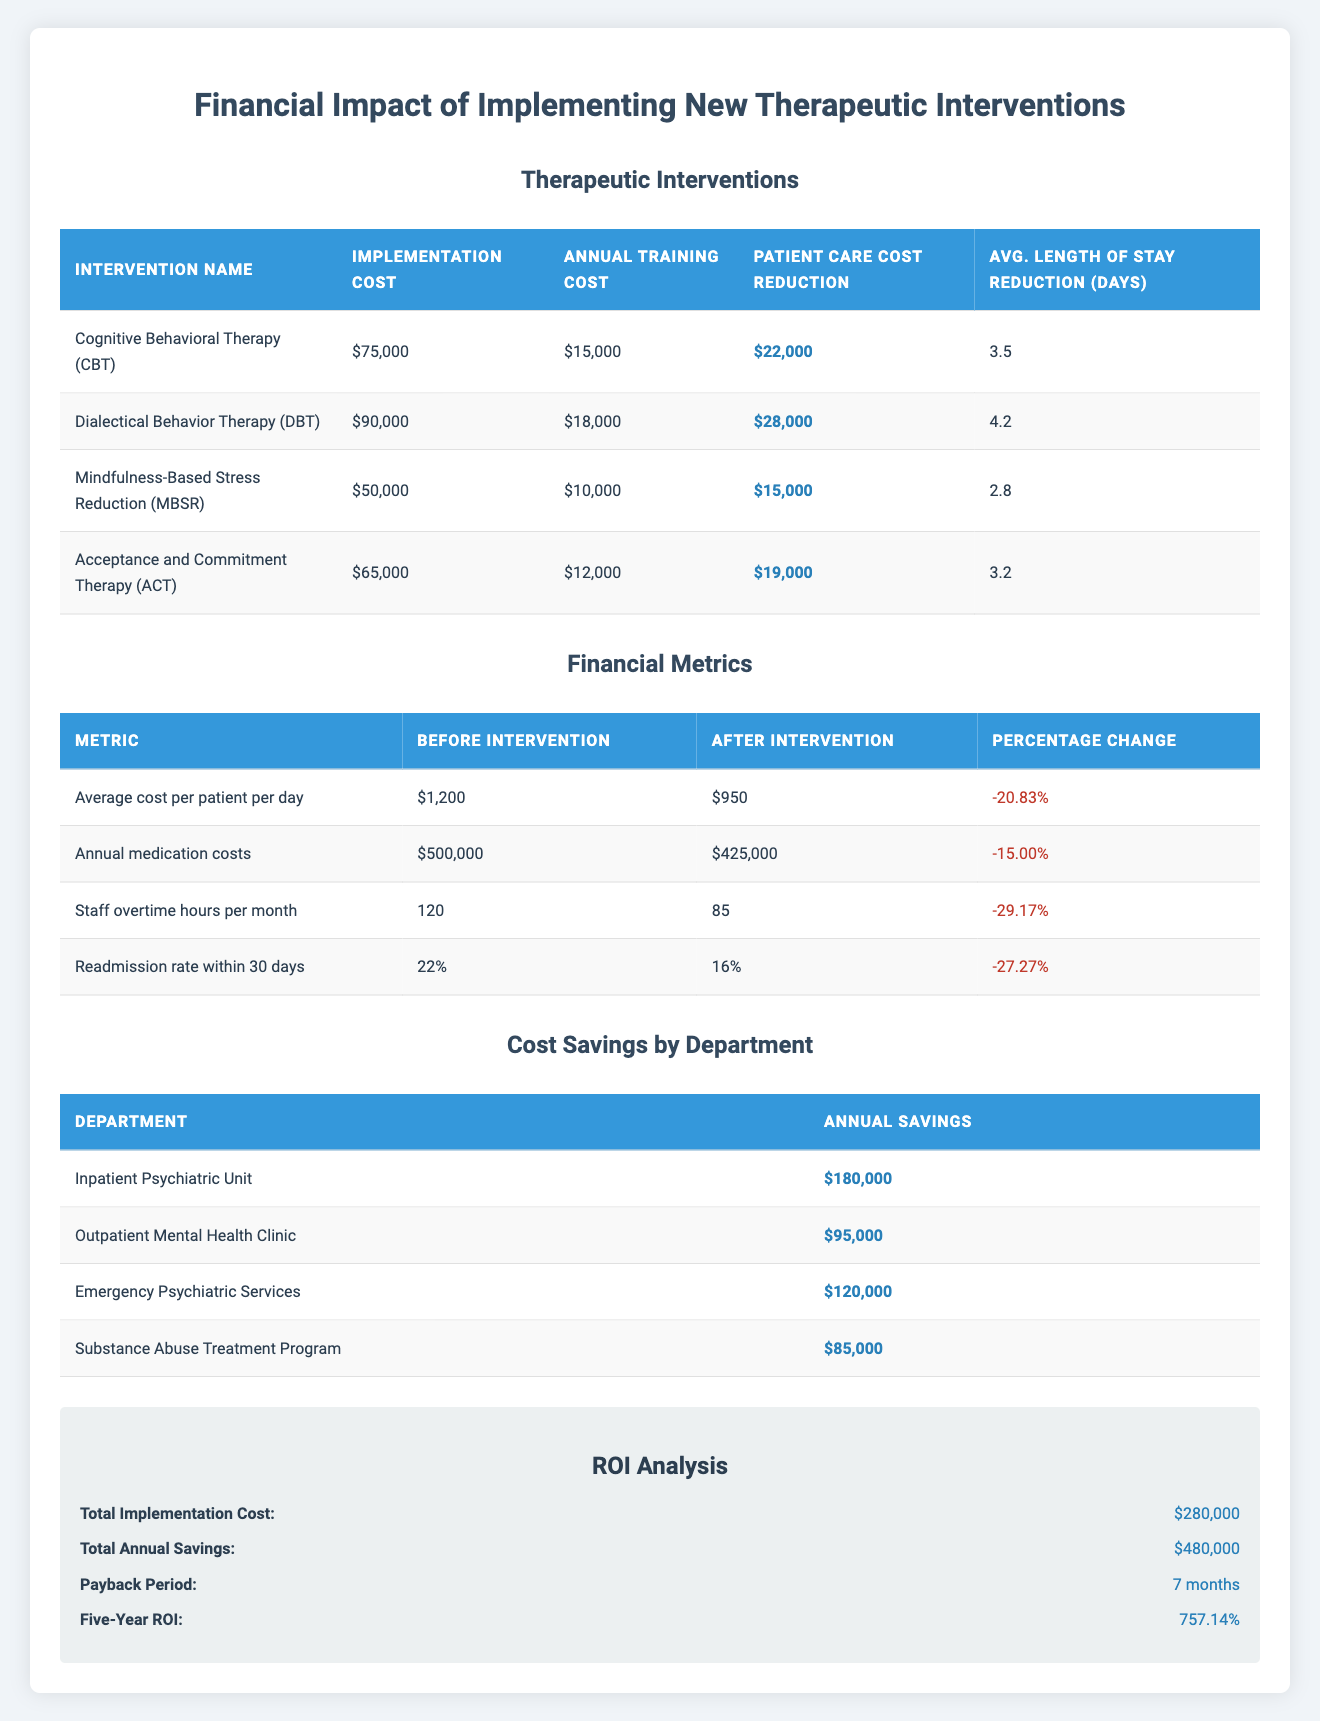What is the implementation cost of Dialectical Behavior Therapy (DBT)? The implementation cost of DBT is listed in the table as $90,000.
Answer: $90,000 What is the annual training cost for Mindfulness-Based Stress Reduction (MBSR)? The annual training cost for MBSR can be found in the table and is stated as $10,000.
Answer: $10,000 How much did patient care costs reduce with Cognitive Behavioral Therapy (CBT)? The reduction in patient care costs associated with CBT is noted in the table as $22,000.
Answer: $22,000 What is the total annual savings across all departments listed? By adding the annual savings from each department: 180,000 + 95,000 + 120,000 + 85,000 = 480,000.
Answer: $480,000 Did the implementation of these interventions reduce the average cost per patient per day? Yes, the average cost per patient per day decreased from $1,200 to $950, indicating a reduction.
Answer: Yes What is the average length of stay reduction for Dialectical Behavior Therapy (DBT)? The reduction in the average length of stay for DBT is specifically mentioned in the table and is 4.2 days.
Answer: 4.2 days How much is the payback period in months for the total implementation cost of the interventions? The payback period is directly provided in the ROI analysis section of the table, which states it is 7 months.
Answer: 7 months What is the percentage change in readmission rates within 30 days after the interventions? The table shows the readmission rate changed from 22% to 16%, resulting in a percentage change of -27.27%.
Answer: -27.27% If we want to find the average patient care cost reduction for all interventions, what would it be? To find the average, sum the reductions ($22,000 + $28,000 + $15,000 + $19,000 = $84,000) and divide by 4 (the number of interventions), resulting in 84,000 / 4 = 21,000.
Answer: $21,000 